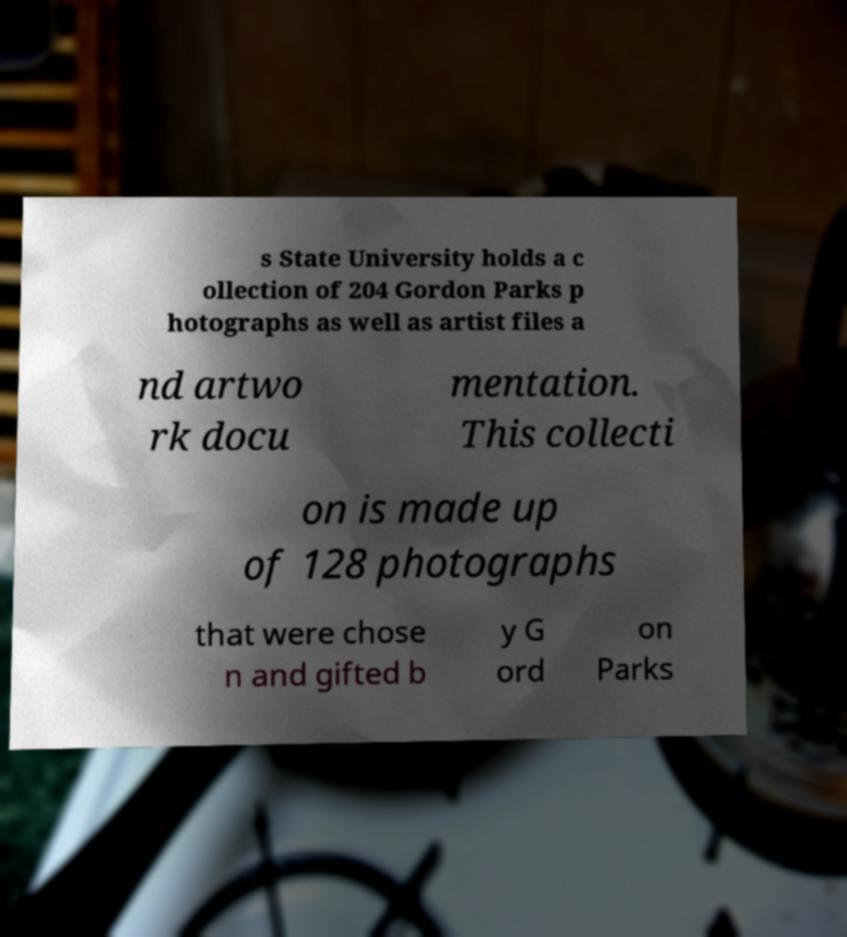Could you extract and type out the text from this image? s State University holds a c ollection of 204 Gordon Parks p hotographs as well as artist files a nd artwo rk docu mentation. This collecti on is made up of 128 photographs that were chose n and gifted b y G ord on Parks 